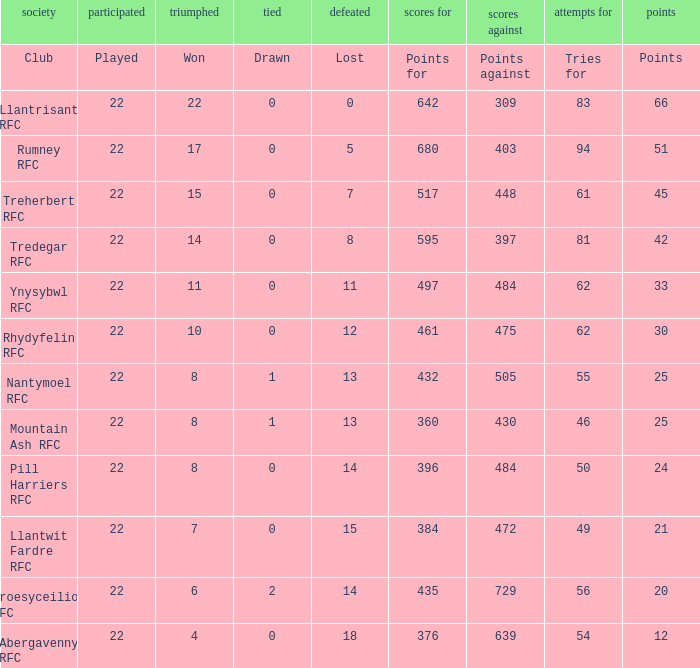For teams that won exactly 15, how many points were scored? 45.0. 